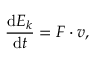<formula> <loc_0><loc_0><loc_500><loc_500>{ \frac { d E _ { k } } { d t } } = F \cdot v ,</formula> 